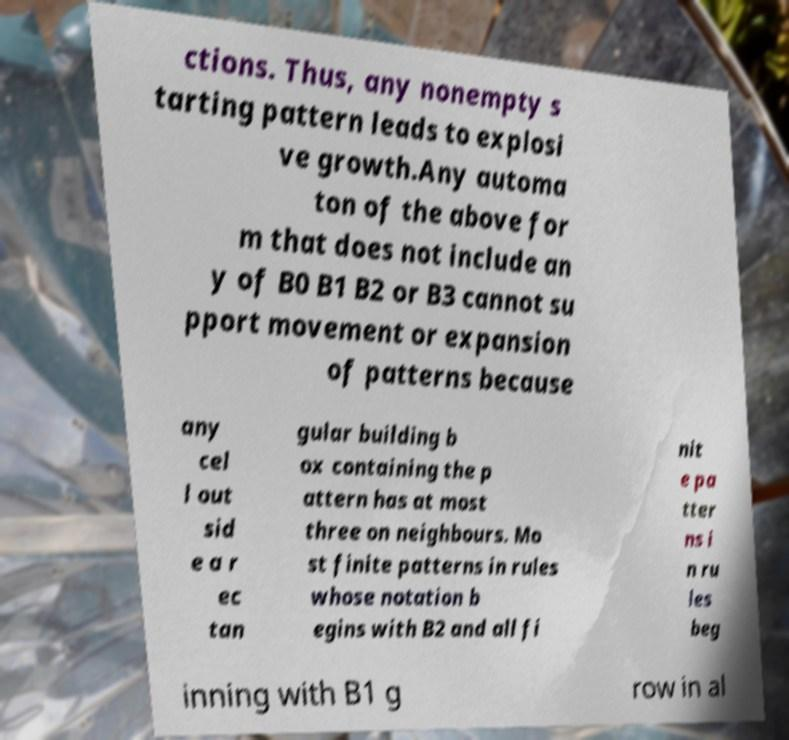For documentation purposes, I need the text within this image transcribed. Could you provide that? ctions. Thus, any nonempty s tarting pattern leads to explosi ve growth.Any automa ton of the above for m that does not include an y of B0 B1 B2 or B3 cannot su pport movement or expansion of patterns because any cel l out sid e a r ec tan gular building b ox containing the p attern has at most three on neighbours. Mo st finite patterns in rules whose notation b egins with B2 and all fi nit e pa tter ns i n ru les beg inning with B1 g row in al 